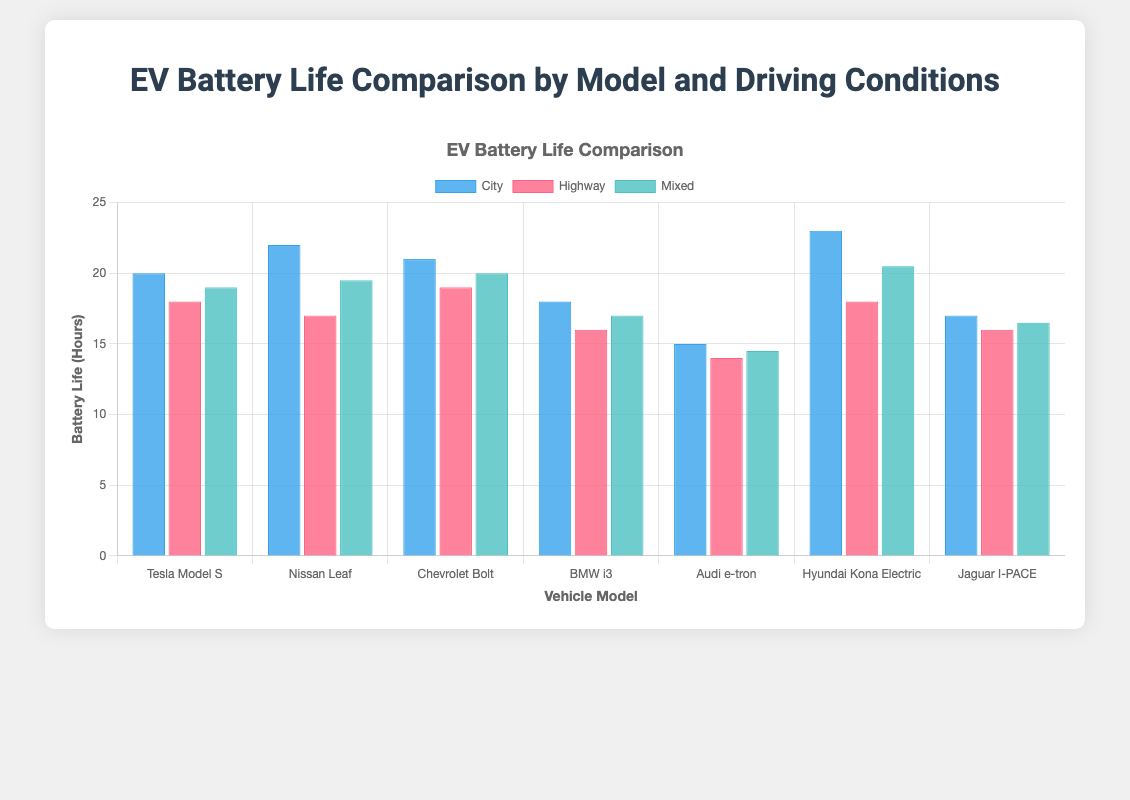Which vehicle model has the highest battery life in city driving conditions? By examining the bar representing city driving conditions, we see that the Hyundai Kona Electric has the tallest bar, indicating it has the highest battery life in city driving conditions.
Answer: Hyundai Kona Electric How does the battery life of the BMW i3 in highway conditions compare to the Chevrolet Bolt in highway conditions? The battery life of the BMW i3 in highway conditions is 16 hours, whereas the Chevrolet Bolt has a battery life of 19 hours in highway conditions. Comparing these, the Chevrolet Bolt has a longer battery life.
Answer: The Chevrolet Bolt has a longer highway battery life What is the average battery life of the Tesla Model S across all driving conditions? The Tesla Model S has battery lives of 20 hours (City), 18 hours (Highway), and 19 hours (Mixed). Summing these values gives 57 hours. Dividing by the 3 conditions, we get 57/3 = 19 hours.
Answer: 19 hours Which driving condition shows the most significant variation in battery life across all vehicle models? By visually comparing the height of the bars for each driving condition, it is evident that highway conditions have the greatest variation in bar heights, indicating the most significant variation in battery life across vehicle models.
Answer: Highway Is there any vehicle model with consistent battery life across all driving conditions? By comparing the bars for each model, none of the vehicle models have perfectly equal battery lives across city, highway, and mixed conditions. The closest is the Jaguar I-PACE with 17, 16, and 16.5 hours but still not perfectly consistent.
Answer: No Which vehicle has the shortest battery life in mixed driving conditions? Looking at the bars representing mixed driving conditions, the shortest one belongs to the Audi e-tron, indicating it has the shortest battery life in mixed conditions.
Answer: Audi e-tron Calculate the difference in battery life between city and highway conditions for the Nissan Leaf. The battery life in city conditions for the Nissan Leaf is 22 hours, while in highway conditions, it is 17 hours. Subtracting these values gives 22 - 17 = 5 hours.
Answer: 5 hours What is the total battery life for the Chevrolet Bolt across all driving conditions? The Chevrolet Bolt's battery life is 21 hours (City), 19 hours (Highway), and 20 hours (Mixed). Summing these values, we get 21 + 19 + 20 = 60 hours.
Answer: 60 hours Which driving condition generally results in the highest battery life across most vehicle models? Examining the bar heights for each driving condition, city driving conditions generally result in the highest battery life across most vehicle models.
Answer: City driving conditions Compare the color and height differences of the battery life bars for the Tesla Model S in mixed and city driving conditions. The mixed condition bar (green) for the Tesla Model S is slightly shorter than the city condition bar (blue). The city bar represents 20 hours, while the mixed bar represents 19 hours.
Answer: The mixed bar is shorter and green, the city bar is taller and blue 